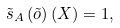Convert formula to latex. <formula><loc_0><loc_0><loc_500><loc_500>\tilde { s } _ { A } \left ( \tilde { o } \right ) ( X ) = 1 ,</formula> 